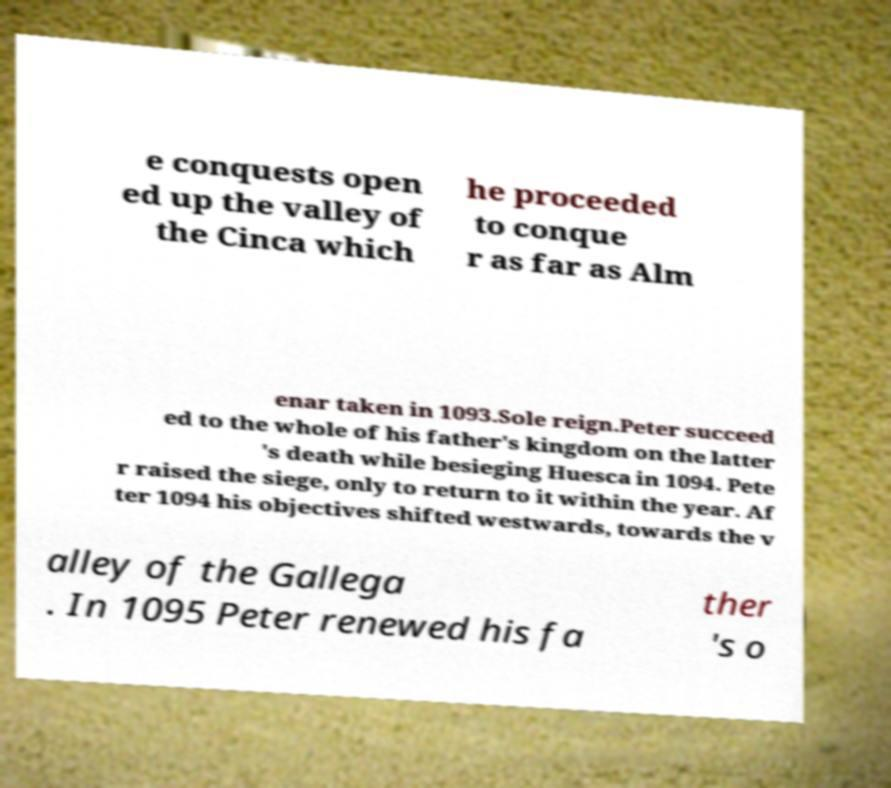Could you extract and type out the text from this image? e conquests open ed up the valley of the Cinca which he proceeded to conque r as far as Alm enar taken in 1093.Sole reign.Peter succeed ed to the whole of his father's kingdom on the latter 's death while besieging Huesca in 1094. Pete r raised the siege, only to return to it within the year. Af ter 1094 his objectives shifted westwards, towards the v alley of the Gallega . In 1095 Peter renewed his fa ther 's o 